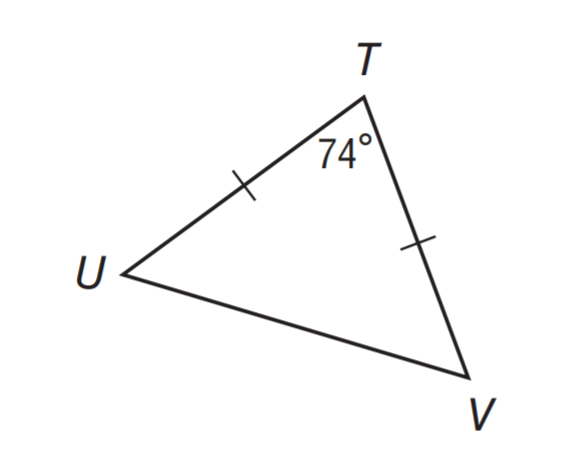Answer the mathemtical geometry problem and directly provide the correct option letter.
Question: Find m \angle T U V.
Choices: A: 16 B: 37 C: 53 D: 74 C 